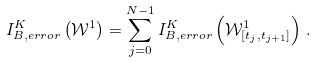<formula> <loc_0><loc_0><loc_500><loc_500>I ^ { K } _ { B , e r r o r } \left ( \mathcal { W } ^ { 1 } \right ) = \sum _ { j = 0 } ^ { N - 1 } I ^ { K } _ { B , e r r o r } \left ( \mathcal { W } ^ { 1 } _ { [ t _ { j } , t _ { j + 1 } ] } \right ) \, .</formula> 